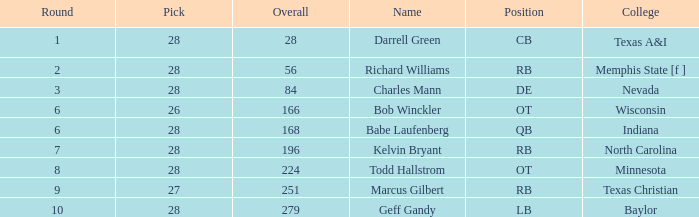For a player from baylor college with a pick below 28, what is their average round? None. 